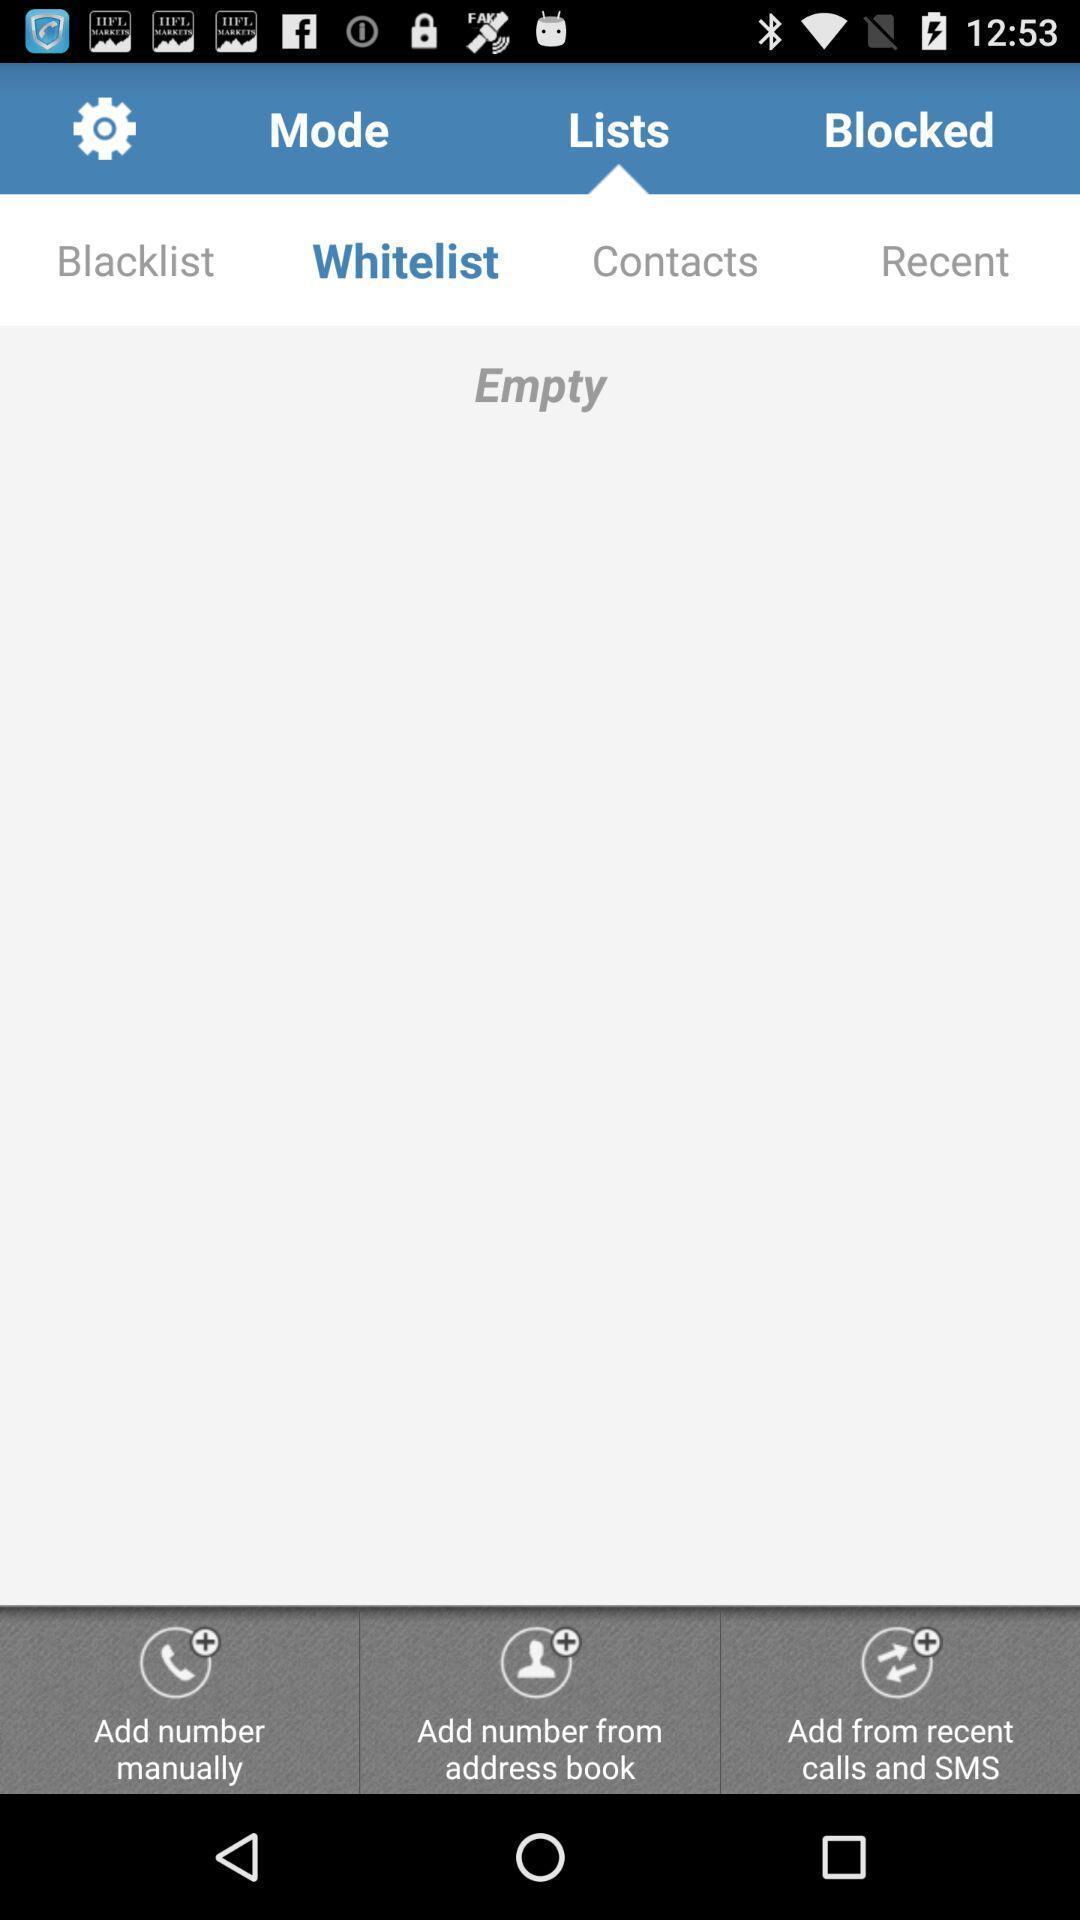Tell me about the visual elements in this screen capture. Settings option showing in this page. 